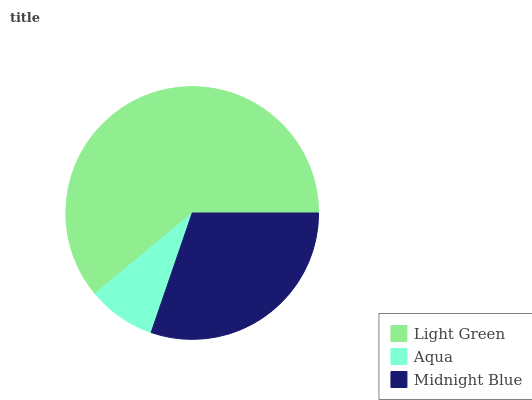Is Aqua the minimum?
Answer yes or no. Yes. Is Light Green the maximum?
Answer yes or no. Yes. Is Midnight Blue the minimum?
Answer yes or no. No. Is Midnight Blue the maximum?
Answer yes or no. No. Is Midnight Blue greater than Aqua?
Answer yes or no. Yes. Is Aqua less than Midnight Blue?
Answer yes or no. Yes. Is Aqua greater than Midnight Blue?
Answer yes or no. No. Is Midnight Blue less than Aqua?
Answer yes or no. No. Is Midnight Blue the high median?
Answer yes or no. Yes. Is Midnight Blue the low median?
Answer yes or no. Yes. Is Aqua the high median?
Answer yes or no. No. Is Aqua the low median?
Answer yes or no. No. 